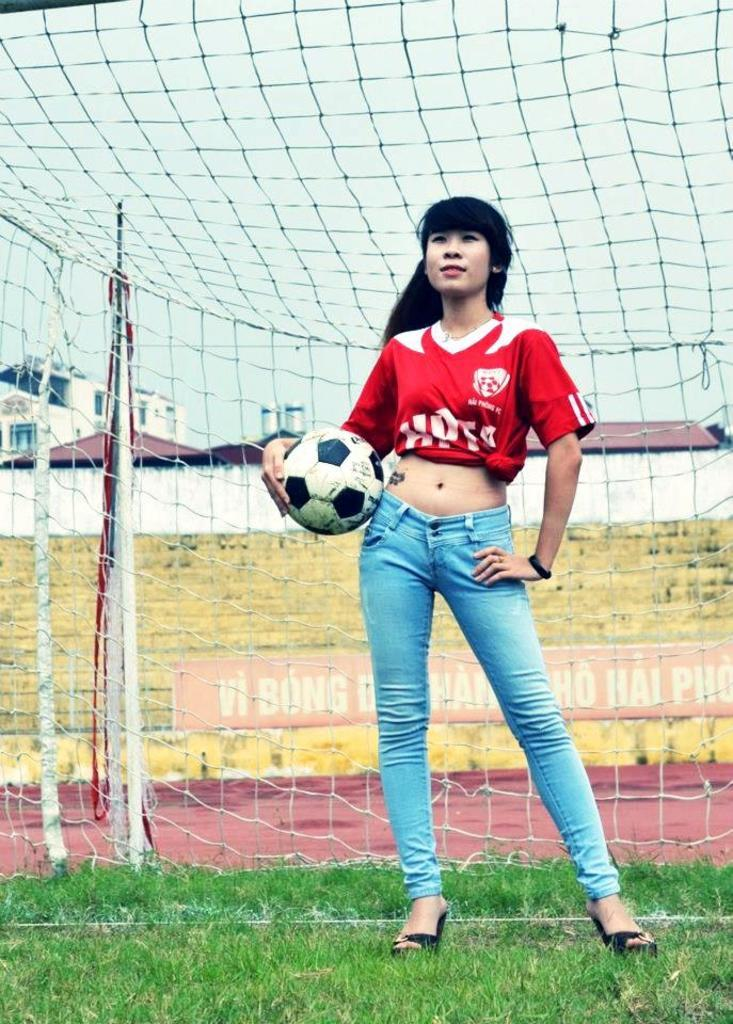What is the woman in the image holding? The woman is holding a ball. What type of surface is visible in the image? There is grass visible in the image. What structure is present in the image? There is a net in the image. Can you describe the background of the image? Grass is visible through the net, and houses are visible in the image. What other objects can be seen in the image? There is a pole, a wall, and a banner in the image. What part of the natural environment is visible in the image? The sky is visible in the image. What type of tin can be seen in the image? There is no tin present in the image. What type of suit is the woman wearing in the image? The image does not show the woman wearing a suit; she is holding a ball. What type of jeans can be seen in the image? There is no mention of jeans in the image. 